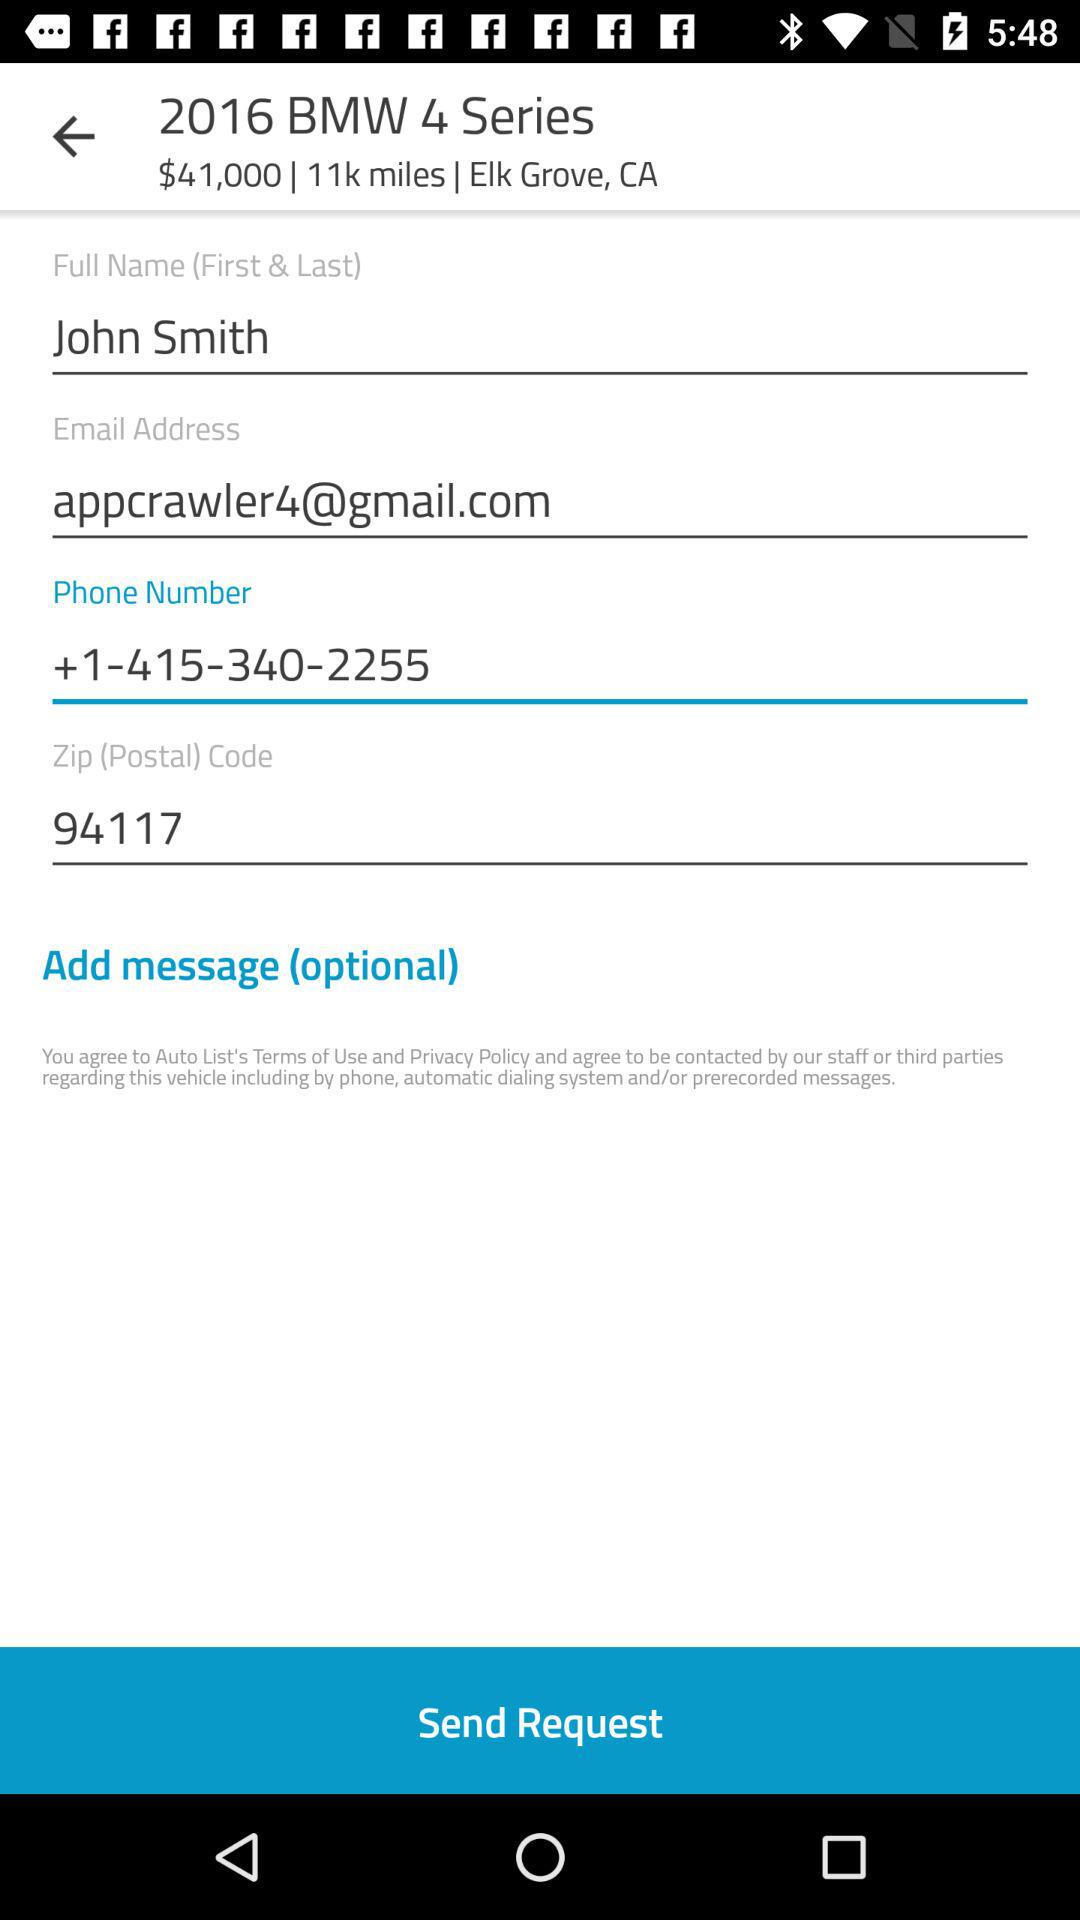What is the email address of the user? The email address of the user is appcrawler4@gmail.com. 